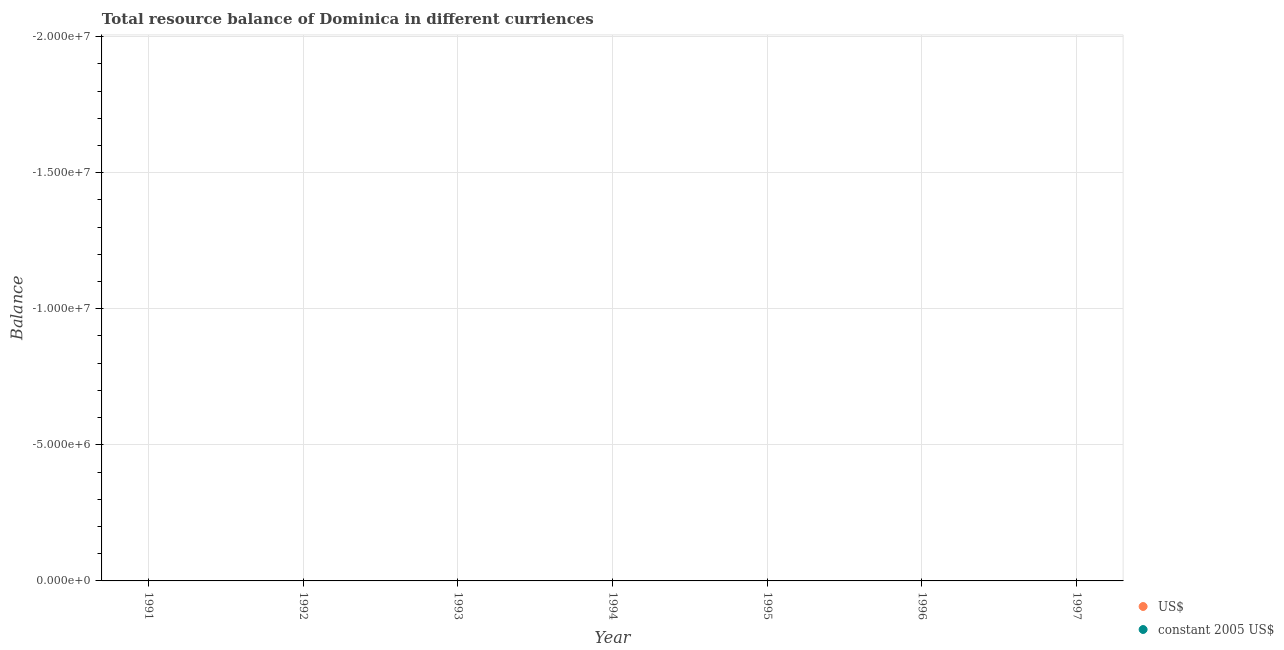What is the difference between the resource balance in constant us$ in 1997 and the resource balance in us$ in 1991?
Provide a short and direct response. 0. Does the resource balance in constant us$ monotonically increase over the years?
Your response must be concise. No. Is the resource balance in constant us$ strictly greater than the resource balance in us$ over the years?
Provide a succinct answer. No. Is the resource balance in us$ strictly less than the resource balance in constant us$ over the years?
Offer a terse response. No. How many dotlines are there?
Offer a terse response. 0. Does the graph contain grids?
Offer a very short reply. Yes. How are the legend labels stacked?
Your answer should be compact. Vertical. What is the title of the graph?
Your answer should be very brief. Total resource balance of Dominica in different curriences. What is the label or title of the Y-axis?
Provide a short and direct response. Balance. What is the Balance in US$ in 1991?
Offer a very short reply. 0. What is the Balance in constant 2005 US$ in 1991?
Your response must be concise. 0. What is the Balance of US$ in 1992?
Provide a succinct answer. 0. What is the Balance in constant 2005 US$ in 1992?
Make the answer very short. 0. What is the Balance in US$ in 1994?
Keep it short and to the point. 0. What is the Balance of US$ in 1995?
Your answer should be very brief. 0. What is the Balance of constant 2005 US$ in 1995?
Make the answer very short. 0. What is the Balance of US$ in 1996?
Your answer should be very brief. 0. What is the Balance in constant 2005 US$ in 1996?
Provide a succinct answer. 0. 